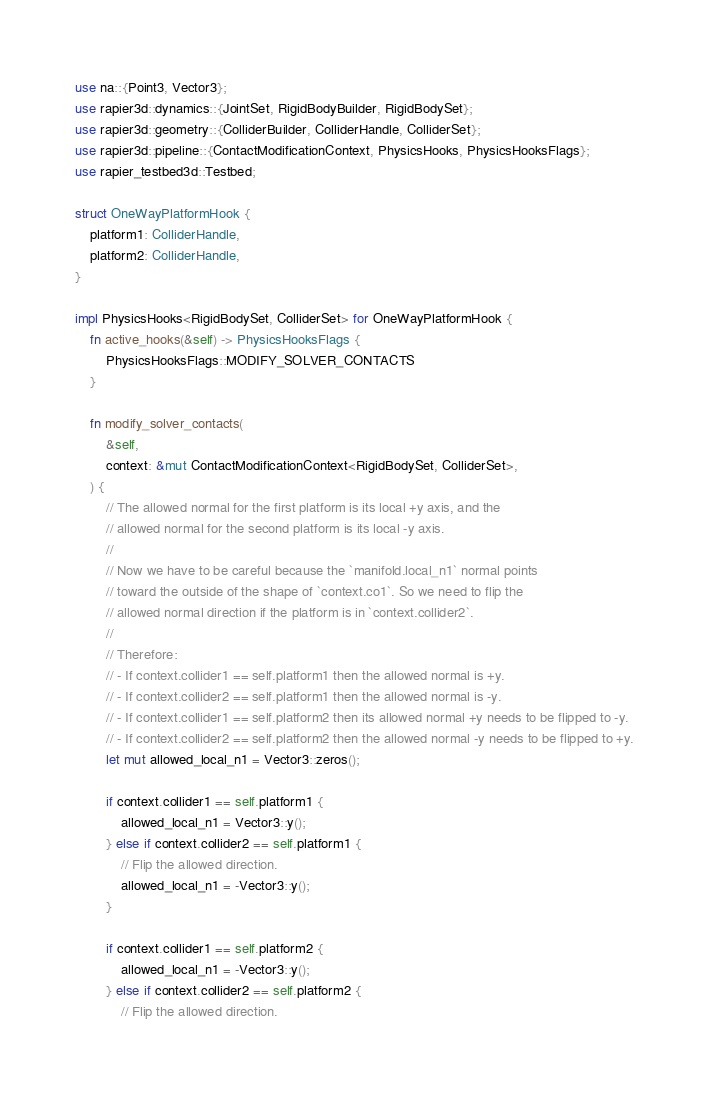Convert code to text. <code><loc_0><loc_0><loc_500><loc_500><_Rust_>use na::{Point3, Vector3};
use rapier3d::dynamics::{JointSet, RigidBodyBuilder, RigidBodySet};
use rapier3d::geometry::{ColliderBuilder, ColliderHandle, ColliderSet};
use rapier3d::pipeline::{ContactModificationContext, PhysicsHooks, PhysicsHooksFlags};
use rapier_testbed3d::Testbed;

struct OneWayPlatformHook {
    platform1: ColliderHandle,
    platform2: ColliderHandle,
}

impl PhysicsHooks<RigidBodySet, ColliderSet> for OneWayPlatformHook {
    fn active_hooks(&self) -> PhysicsHooksFlags {
        PhysicsHooksFlags::MODIFY_SOLVER_CONTACTS
    }

    fn modify_solver_contacts(
        &self,
        context: &mut ContactModificationContext<RigidBodySet, ColliderSet>,
    ) {
        // The allowed normal for the first platform is its local +y axis, and the
        // allowed normal for the second platform is its local -y axis.
        //
        // Now we have to be careful because the `manifold.local_n1` normal points
        // toward the outside of the shape of `context.co1`. So we need to flip the
        // allowed normal direction if the platform is in `context.collider2`.
        //
        // Therefore:
        // - If context.collider1 == self.platform1 then the allowed normal is +y.
        // - If context.collider2 == self.platform1 then the allowed normal is -y.
        // - If context.collider1 == self.platform2 then its allowed normal +y needs to be flipped to -y.
        // - If context.collider2 == self.platform2 then the allowed normal -y needs to be flipped to +y.
        let mut allowed_local_n1 = Vector3::zeros();

        if context.collider1 == self.platform1 {
            allowed_local_n1 = Vector3::y();
        } else if context.collider2 == self.platform1 {
            // Flip the allowed direction.
            allowed_local_n1 = -Vector3::y();
        }

        if context.collider1 == self.platform2 {
            allowed_local_n1 = -Vector3::y();
        } else if context.collider2 == self.platform2 {
            // Flip the allowed direction.</code> 